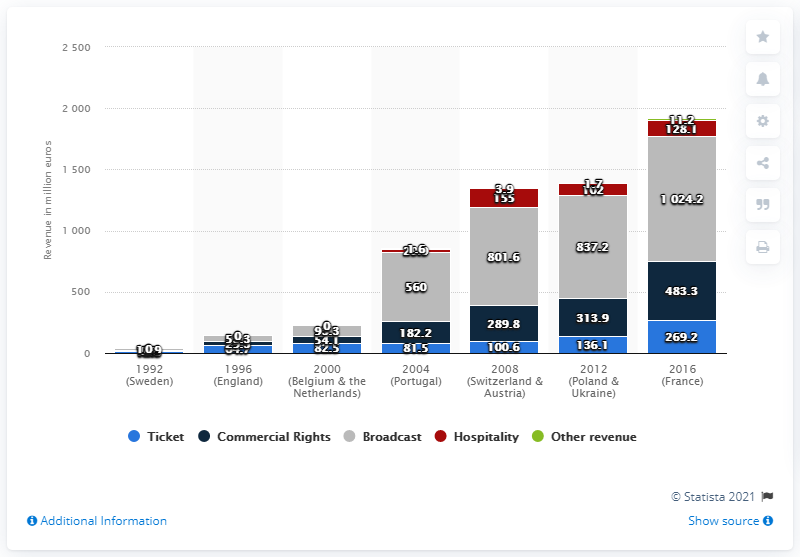Specify some key components in this picture. The revenue generated from broadcasting rights at the 2012 UEFA EURO championship was 837.2 million euros. 